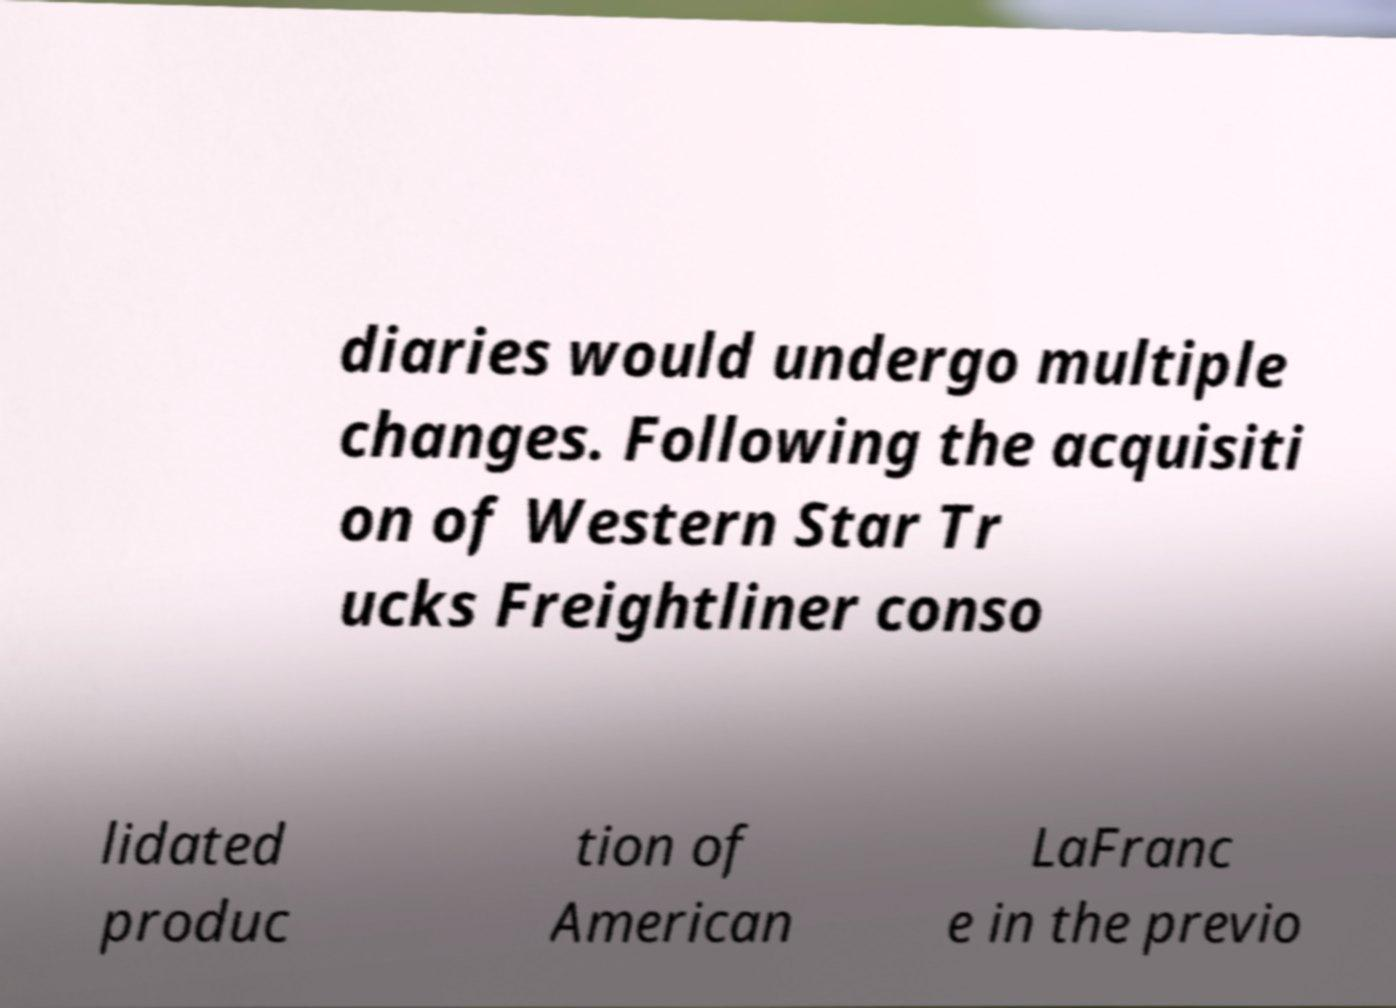Could you assist in decoding the text presented in this image and type it out clearly? diaries would undergo multiple changes. Following the acquisiti on of Western Star Tr ucks Freightliner conso lidated produc tion of American LaFranc e in the previo 